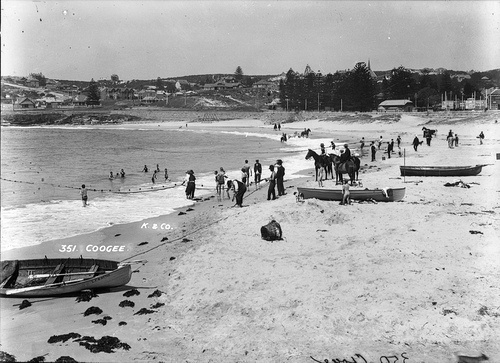Describe the objects in this image and their specific colors. I can see boat in black, gray, darkgray, and lightgray tones, people in black, darkgray, lightgray, and gray tones, boat in black, gray, darkgray, and lightgray tones, boat in black, gray, darkgray, and lightgray tones, and horse in black, gray, darkgray, and lightgray tones in this image. 